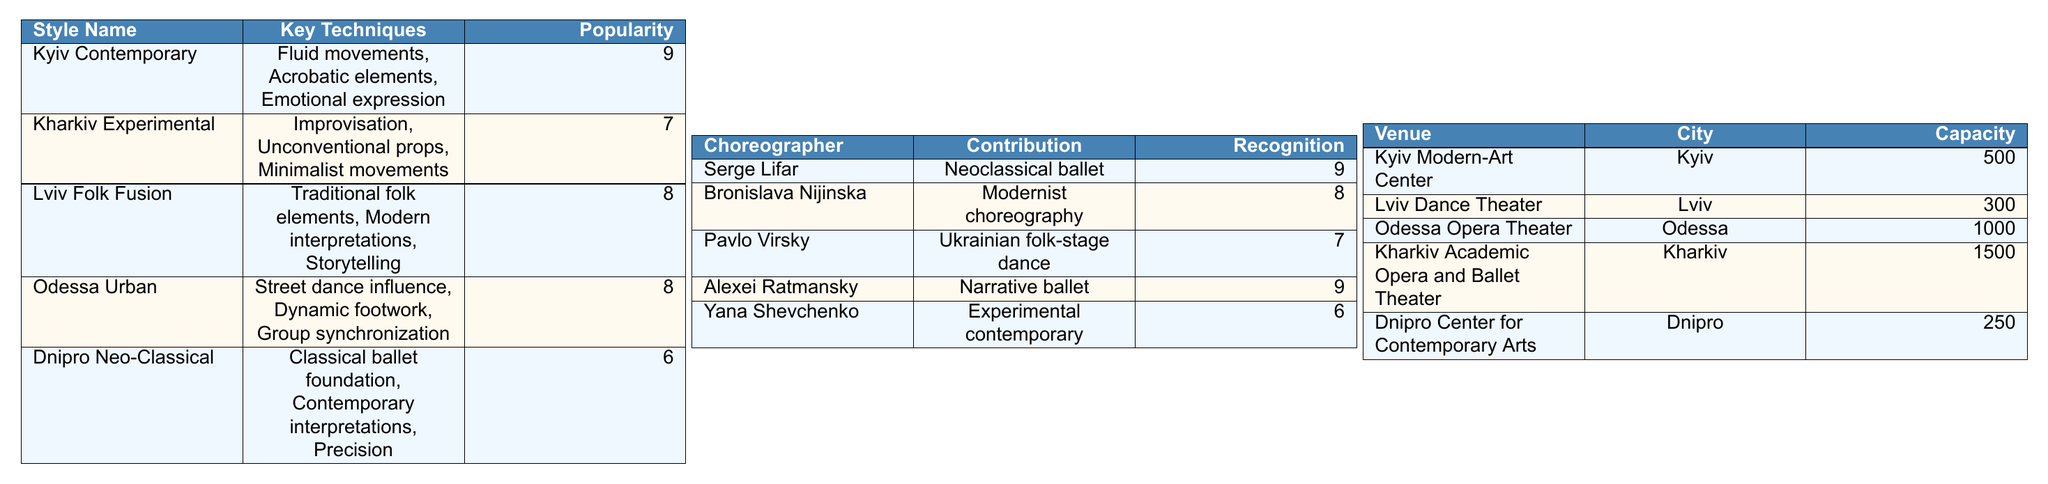What is the founding year of Kyiv Contemporary? The table states that Kyiv Contemporary was established in 2006 under the founding choreographer Radu Poklitaru.
Answer: 2006 Which dance style has the highest popularity rating? The popularity ratings for each style are 9 for Kyiv Contemporary, 7 for Kharkiv Experimental, 8 for Lviv Folk Fusion, 8 for Odessa Urban, and 6 for Dnipro Neo-Classical. The highest rating is 9.
Answer: Kyiv Contemporary What key technique is common between Odessa Urban and Kharkiv Experimental? Both styles include techniques that focus on innovative movement. Odessa Urban employs "Dynamic footwork" and "Group synchronization," while Kharkiv Experimental emphasizes "Improvisation" and "Unconventional props," showcasing a focus on versatility and creativity.
Answer: None, they have different techniques What techniques does Lviv Folk Fusion include? The table lists the key techniques for Lviv Folk Fusion as "Traditional folk elements," "Modern interpretations," and "Storytelling."
Answer: Traditional folk elements, Modern interpretations, Storytelling What percentage of the dance styles established before 2010 have a popularity rating of 8 or higher? The styles established before 2010 are Kyiv Contemporary (9), Lviv Folk Fusion (8), and Dnipro Neo-Classical (6). Out of 3 styles, 2 have ratings of 8 or higher (Kyiv Contemporary and Lviv Folk Fusion), resulting in 66.67%.
Answer: 66.67% Is there any dance style influenced by Hip-hop? Odessa Urban is the style influenced by Hip-hop as stated in the table.
Answer: Yes Which choreographer is associated with Kharkiv Experimental? The founding choreographer of Kharkiv Experimental is Olga Svoboda, as per the table.
Answer: Olga Svoboda What is the average capacity of the listed dance venues? To find the average, sum the capacities (500 + 300 + 1000 + 1500 + 250) = 2550, then divide by the total number of venues (5). So, 2550/5 = 510.
Answer: 510 Which choreographer has the highest international recognition rating? Comparing the recognition ratings, Serge Lifar and Alexei Ratmansky both have a rating of 9, which is the highest.
Answer: Serge Lifar and Alexei Ratmansky Which contemporary dance venue has the largest capacity? The table indicates that Kharkiv Academic Opera and Ballet Theater has a capacity of 1500, the largest among the venues listed.
Answer: Kharkiv Academic Opera and Ballet Theater 